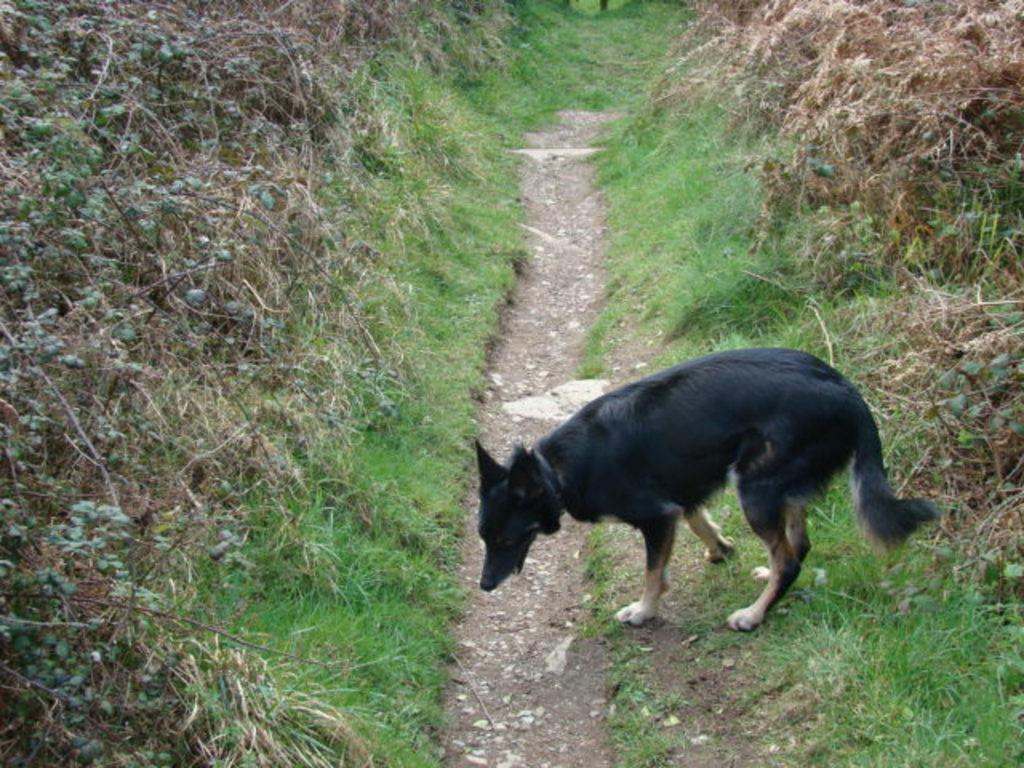Describe this image in one or two sentences. In this picture there is a black color dog standing near to the grass. There is a dry grass. 